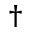Convert formula to latex. <formula><loc_0><loc_0><loc_500><loc_500>^ { \dagger }</formula> 